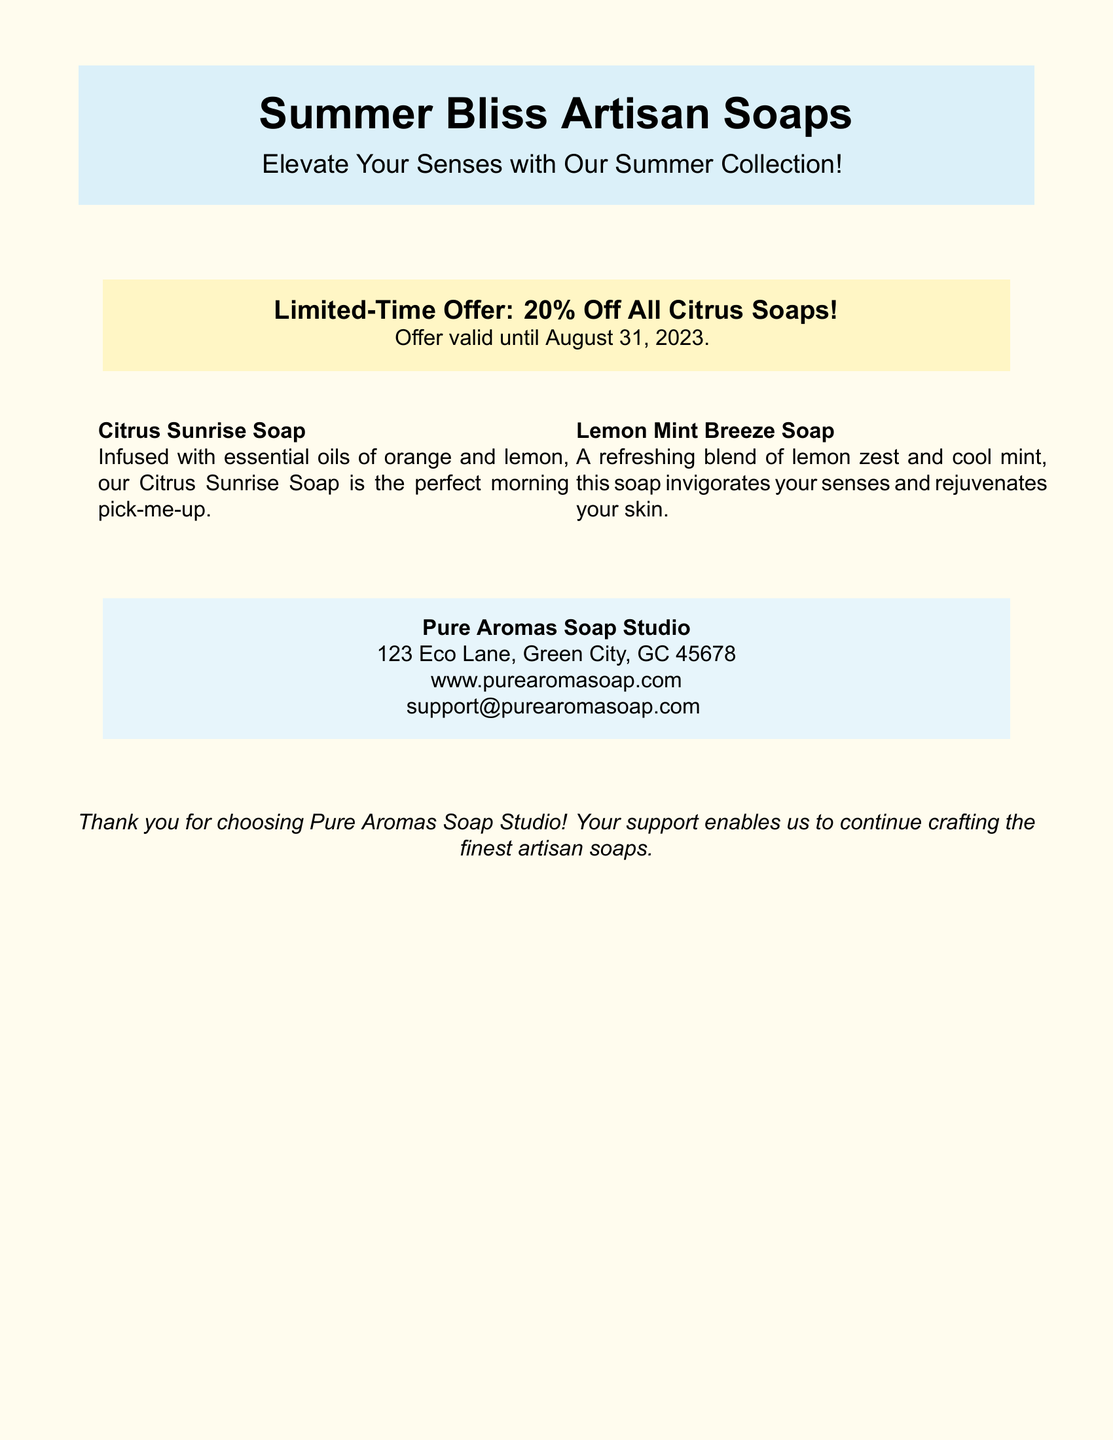What is the name of the soap collection? The soap collection is named in the document as "Summer Bliss Artisan Soaps."
Answer: Summer Bliss Artisan Soaps What is the discount amount for the citrus soaps? The document states a "Limited-Time Offer" for a specific discount on citrus soaps.
Answer: 20% Off When does the offer on citrus soaps expire? The document provides a validity date for the promotional offer.
Answer: August 31, 2023 What two soaps are mentioned in the promotion? The document lists two specific soap products as part of the promotion.
Answer: Citrus Sunrise Soap, Lemon Mint Breeze Soap What is the address of Pure Aromas Soap Studio? The document includes the physical address of the company.
Answer: 123 Eco Lane, Green City, GC 45678 What phrase is used to describe the benefits of the Citrus Sunrise Soap? The document describes the effects of the Citrus Sunrise Soap in a specific phrase.
Answer: morning pick-me-up Who can you contact for support? The document is clear on how to reach out for customer support, specifying an email.
Answer: support@purearomasoap.com What type of document is this? The overall structure and information presented suggest the nature of the document.
Answer: Shipping label What color theme is used for the document background? The document implies a specific color theme for its presentation.
Answer: summeryellow 